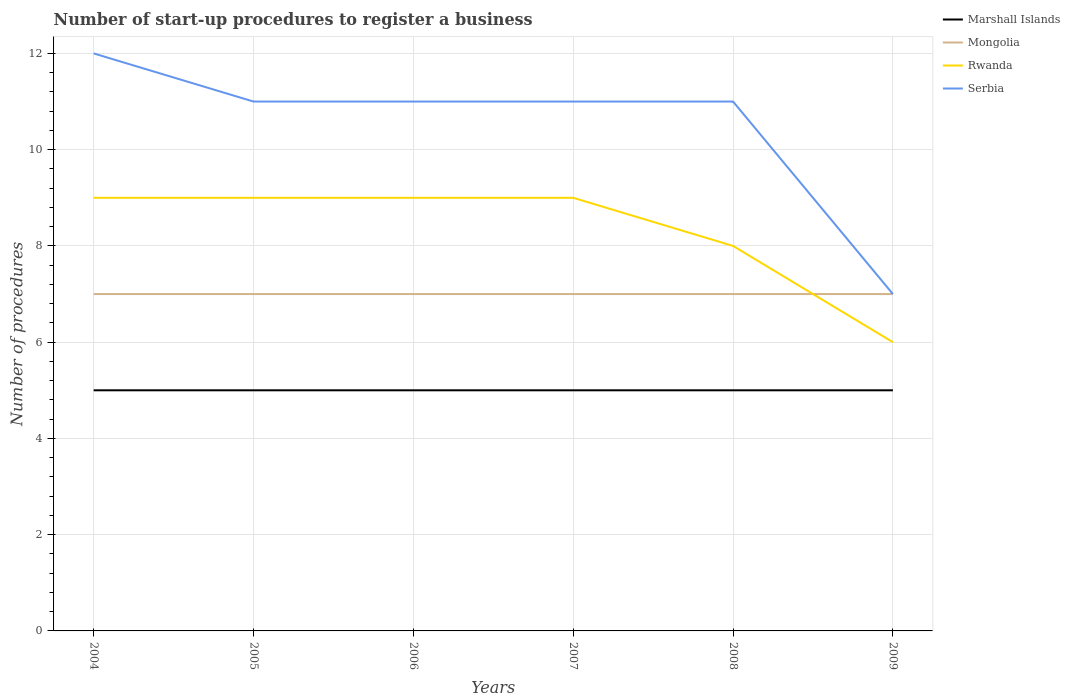How many different coloured lines are there?
Offer a terse response. 4. Does the line corresponding to Marshall Islands intersect with the line corresponding to Rwanda?
Ensure brevity in your answer.  No. Across all years, what is the maximum number of procedures required to register a business in Mongolia?
Offer a terse response. 7. In which year was the number of procedures required to register a business in Mongolia maximum?
Give a very brief answer. 2004. What is the difference between the highest and the second highest number of procedures required to register a business in Serbia?
Give a very brief answer. 5. How many years are there in the graph?
Offer a very short reply. 6. What is the difference between two consecutive major ticks on the Y-axis?
Provide a succinct answer. 2. Does the graph contain any zero values?
Your answer should be very brief. No. Does the graph contain grids?
Provide a succinct answer. Yes. How many legend labels are there?
Offer a very short reply. 4. How are the legend labels stacked?
Your answer should be compact. Vertical. What is the title of the graph?
Your answer should be very brief. Number of start-up procedures to register a business. Does "Luxembourg" appear as one of the legend labels in the graph?
Offer a very short reply. No. What is the label or title of the Y-axis?
Your response must be concise. Number of procedures. What is the Number of procedures of Marshall Islands in 2004?
Provide a succinct answer. 5. What is the Number of procedures of Rwanda in 2004?
Provide a succinct answer. 9. What is the Number of procedures of Marshall Islands in 2005?
Provide a short and direct response. 5. What is the Number of procedures of Rwanda in 2005?
Your response must be concise. 9. What is the Number of procedures in Mongolia in 2006?
Provide a short and direct response. 7. What is the Number of procedures in Rwanda in 2006?
Your answer should be very brief. 9. What is the Number of procedures of Mongolia in 2007?
Make the answer very short. 7. What is the Number of procedures in Rwanda in 2007?
Offer a terse response. 9. What is the Number of procedures in Mongolia in 2008?
Your answer should be compact. 7. What is the Number of procedures in Serbia in 2008?
Your answer should be compact. 11. What is the Number of procedures in Serbia in 2009?
Provide a succinct answer. 7. Across all years, what is the maximum Number of procedures of Marshall Islands?
Provide a succinct answer. 5. Across all years, what is the maximum Number of procedures in Mongolia?
Your answer should be compact. 7. Across all years, what is the maximum Number of procedures in Rwanda?
Keep it short and to the point. 9. Across all years, what is the minimum Number of procedures in Marshall Islands?
Your answer should be very brief. 5. Across all years, what is the minimum Number of procedures of Rwanda?
Offer a very short reply. 6. What is the total Number of procedures in Marshall Islands in the graph?
Ensure brevity in your answer.  30. What is the difference between the Number of procedures of Marshall Islands in 2004 and that in 2005?
Your response must be concise. 0. What is the difference between the Number of procedures of Mongolia in 2004 and that in 2005?
Offer a terse response. 0. What is the difference between the Number of procedures in Rwanda in 2004 and that in 2005?
Your response must be concise. 0. What is the difference between the Number of procedures in Serbia in 2004 and that in 2005?
Your answer should be compact. 1. What is the difference between the Number of procedures of Mongolia in 2004 and that in 2006?
Your answer should be very brief. 0. What is the difference between the Number of procedures of Serbia in 2004 and that in 2006?
Your answer should be compact. 1. What is the difference between the Number of procedures of Marshall Islands in 2004 and that in 2007?
Provide a succinct answer. 0. What is the difference between the Number of procedures in Serbia in 2004 and that in 2007?
Give a very brief answer. 1. What is the difference between the Number of procedures in Marshall Islands in 2004 and that in 2008?
Your response must be concise. 0. What is the difference between the Number of procedures in Rwanda in 2004 and that in 2008?
Offer a terse response. 1. What is the difference between the Number of procedures of Marshall Islands in 2004 and that in 2009?
Your answer should be very brief. 0. What is the difference between the Number of procedures of Mongolia in 2004 and that in 2009?
Offer a terse response. 0. What is the difference between the Number of procedures of Serbia in 2004 and that in 2009?
Provide a short and direct response. 5. What is the difference between the Number of procedures in Marshall Islands in 2005 and that in 2006?
Ensure brevity in your answer.  0. What is the difference between the Number of procedures in Mongolia in 2005 and that in 2006?
Offer a very short reply. 0. What is the difference between the Number of procedures in Rwanda in 2005 and that in 2006?
Ensure brevity in your answer.  0. What is the difference between the Number of procedures in Serbia in 2005 and that in 2006?
Keep it short and to the point. 0. What is the difference between the Number of procedures of Marshall Islands in 2005 and that in 2007?
Your answer should be compact. 0. What is the difference between the Number of procedures in Mongolia in 2005 and that in 2007?
Ensure brevity in your answer.  0. What is the difference between the Number of procedures of Marshall Islands in 2005 and that in 2008?
Ensure brevity in your answer.  0. What is the difference between the Number of procedures in Rwanda in 2005 and that in 2008?
Keep it short and to the point. 1. What is the difference between the Number of procedures of Serbia in 2005 and that in 2008?
Provide a short and direct response. 0. What is the difference between the Number of procedures of Mongolia in 2005 and that in 2009?
Keep it short and to the point. 0. What is the difference between the Number of procedures of Mongolia in 2006 and that in 2007?
Keep it short and to the point. 0. What is the difference between the Number of procedures in Serbia in 2006 and that in 2007?
Keep it short and to the point. 0. What is the difference between the Number of procedures in Mongolia in 2006 and that in 2008?
Your response must be concise. 0. What is the difference between the Number of procedures in Rwanda in 2006 and that in 2008?
Make the answer very short. 1. What is the difference between the Number of procedures in Serbia in 2006 and that in 2008?
Your answer should be very brief. 0. What is the difference between the Number of procedures in Marshall Islands in 2006 and that in 2009?
Ensure brevity in your answer.  0. What is the difference between the Number of procedures in Rwanda in 2006 and that in 2009?
Ensure brevity in your answer.  3. What is the difference between the Number of procedures of Marshall Islands in 2007 and that in 2008?
Keep it short and to the point. 0. What is the difference between the Number of procedures in Mongolia in 2007 and that in 2008?
Ensure brevity in your answer.  0. What is the difference between the Number of procedures of Rwanda in 2007 and that in 2008?
Your response must be concise. 1. What is the difference between the Number of procedures of Marshall Islands in 2007 and that in 2009?
Provide a short and direct response. 0. What is the difference between the Number of procedures in Mongolia in 2007 and that in 2009?
Make the answer very short. 0. What is the difference between the Number of procedures in Marshall Islands in 2008 and that in 2009?
Make the answer very short. 0. What is the difference between the Number of procedures of Mongolia in 2008 and that in 2009?
Keep it short and to the point. 0. What is the difference between the Number of procedures in Rwanda in 2008 and that in 2009?
Provide a succinct answer. 2. What is the difference between the Number of procedures of Serbia in 2008 and that in 2009?
Your answer should be compact. 4. What is the difference between the Number of procedures in Marshall Islands in 2004 and the Number of procedures in Mongolia in 2005?
Your answer should be very brief. -2. What is the difference between the Number of procedures of Marshall Islands in 2004 and the Number of procedures of Rwanda in 2005?
Give a very brief answer. -4. What is the difference between the Number of procedures of Mongolia in 2004 and the Number of procedures of Rwanda in 2005?
Provide a short and direct response. -2. What is the difference between the Number of procedures of Mongolia in 2004 and the Number of procedures of Serbia in 2005?
Provide a succinct answer. -4. What is the difference between the Number of procedures of Marshall Islands in 2004 and the Number of procedures of Mongolia in 2006?
Make the answer very short. -2. What is the difference between the Number of procedures in Rwanda in 2004 and the Number of procedures in Serbia in 2006?
Make the answer very short. -2. What is the difference between the Number of procedures in Marshall Islands in 2004 and the Number of procedures in Mongolia in 2007?
Provide a succinct answer. -2. What is the difference between the Number of procedures of Marshall Islands in 2004 and the Number of procedures of Rwanda in 2007?
Make the answer very short. -4. What is the difference between the Number of procedures of Mongolia in 2004 and the Number of procedures of Rwanda in 2007?
Make the answer very short. -2. What is the difference between the Number of procedures of Mongolia in 2004 and the Number of procedures of Serbia in 2007?
Ensure brevity in your answer.  -4. What is the difference between the Number of procedures in Marshall Islands in 2004 and the Number of procedures in Mongolia in 2008?
Offer a very short reply. -2. What is the difference between the Number of procedures of Marshall Islands in 2004 and the Number of procedures of Rwanda in 2008?
Give a very brief answer. -3. What is the difference between the Number of procedures in Marshall Islands in 2004 and the Number of procedures in Serbia in 2008?
Offer a very short reply. -6. What is the difference between the Number of procedures in Rwanda in 2004 and the Number of procedures in Serbia in 2008?
Ensure brevity in your answer.  -2. What is the difference between the Number of procedures in Marshall Islands in 2004 and the Number of procedures in Mongolia in 2009?
Your response must be concise. -2. What is the difference between the Number of procedures in Marshall Islands in 2004 and the Number of procedures in Rwanda in 2009?
Offer a very short reply. -1. What is the difference between the Number of procedures of Mongolia in 2004 and the Number of procedures of Rwanda in 2009?
Give a very brief answer. 1. What is the difference between the Number of procedures in Marshall Islands in 2005 and the Number of procedures in Mongolia in 2006?
Offer a terse response. -2. What is the difference between the Number of procedures of Marshall Islands in 2005 and the Number of procedures of Rwanda in 2006?
Your response must be concise. -4. What is the difference between the Number of procedures in Marshall Islands in 2005 and the Number of procedures in Serbia in 2006?
Your answer should be compact. -6. What is the difference between the Number of procedures of Mongolia in 2005 and the Number of procedures of Rwanda in 2006?
Give a very brief answer. -2. What is the difference between the Number of procedures of Mongolia in 2005 and the Number of procedures of Serbia in 2006?
Provide a succinct answer. -4. What is the difference between the Number of procedures of Marshall Islands in 2005 and the Number of procedures of Mongolia in 2007?
Provide a succinct answer. -2. What is the difference between the Number of procedures of Mongolia in 2005 and the Number of procedures of Rwanda in 2007?
Your response must be concise. -2. What is the difference between the Number of procedures in Mongolia in 2005 and the Number of procedures in Serbia in 2007?
Make the answer very short. -4. What is the difference between the Number of procedures in Mongolia in 2005 and the Number of procedures in Rwanda in 2008?
Your answer should be compact. -1. What is the difference between the Number of procedures of Mongolia in 2005 and the Number of procedures of Serbia in 2008?
Provide a short and direct response. -4. What is the difference between the Number of procedures of Marshall Islands in 2005 and the Number of procedures of Mongolia in 2009?
Keep it short and to the point. -2. What is the difference between the Number of procedures in Mongolia in 2005 and the Number of procedures in Serbia in 2009?
Your response must be concise. 0. What is the difference between the Number of procedures in Marshall Islands in 2006 and the Number of procedures in Mongolia in 2007?
Offer a very short reply. -2. What is the difference between the Number of procedures of Marshall Islands in 2006 and the Number of procedures of Rwanda in 2007?
Keep it short and to the point. -4. What is the difference between the Number of procedures of Marshall Islands in 2006 and the Number of procedures of Serbia in 2007?
Make the answer very short. -6. What is the difference between the Number of procedures in Mongolia in 2006 and the Number of procedures in Rwanda in 2007?
Give a very brief answer. -2. What is the difference between the Number of procedures in Rwanda in 2006 and the Number of procedures in Serbia in 2007?
Offer a very short reply. -2. What is the difference between the Number of procedures in Marshall Islands in 2006 and the Number of procedures in Mongolia in 2008?
Keep it short and to the point. -2. What is the difference between the Number of procedures of Mongolia in 2006 and the Number of procedures of Rwanda in 2008?
Make the answer very short. -1. What is the difference between the Number of procedures in Marshall Islands in 2006 and the Number of procedures in Mongolia in 2009?
Make the answer very short. -2. What is the difference between the Number of procedures of Marshall Islands in 2006 and the Number of procedures of Rwanda in 2009?
Give a very brief answer. -1. What is the difference between the Number of procedures in Mongolia in 2006 and the Number of procedures in Serbia in 2009?
Provide a succinct answer. 0. What is the difference between the Number of procedures of Rwanda in 2006 and the Number of procedures of Serbia in 2009?
Provide a short and direct response. 2. What is the difference between the Number of procedures in Marshall Islands in 2007 and the Number of procedures in Mongolia in 2008?
Your response must be concise. -2. What is the difference between the Number of procedures of Rwanda in 2007 and the Number of procedures of Serbia in 2008?
Your answer should be very brief. -2. What is the difference between the Number of procedures of Marshall Islands in 2007 and the Number of procedures of Rwanda in 2009?
Your answer should be compact. -1. What is the difference between the Number of procedures of Marshall Islands in 2008 and the Number of procedures of Mongolia in 2009?
Provide a succinct answer. -2. What is the difference between the Number of procedures of Marshall Islands in 2008 and the Number of procedures of Serbia in 2009?
Your response must be concise. -2. What is the difference between the Number of procedures of Mongolia in 2008 and the Number of procedures of Rwanda in 2009?
Make the answer very short. 1. What is the difference between the Number of procedures of Mongolia in 2008 and the Number of procedures of Serbia in 2009?
Your answer should be very brief. 0. What is the difference between the Number of procedures of Rwanda in 2008 and the Number of procedures of Serbia in 2009?
Your answer should be compact. 1. What is the average Number of procedures of Marshall Islands per year?
Your response must be concise. 5. What is the average Number of procedures of Mongolia per year?
Ensure brevity in your answer.  7. What is the average Number of procedures in Rwanda per year?
Provide a short and direct response. 8.33. In the year 2004, what is the difference between the Number of procedures in Marshall Islands and Number of procedures in Mongolia?
Make the answer very short. -2. In the year 2004, what is the difference between the Number of procedures in Mongolia and Number of procedures in Rwanda?
Offer a very short reply. -2. In the year 2004, what is the difference between the Number of procedures in Rwanda and Number of procedures in Serbia?
Your answer should be very brief. -3. In the year 2005, what is the difference between the Number of procedures of Marshall Islands and Number of procedures of Mongolia?
Offer a terse response. -2. In the year 2005, what is the difference between the Number of procedures in Rwanda and Number of procedures in Serbia?
Your response must be concise. -2. In the year 2006, what is the difference between the Number of procedures of Marshall Islands and Number of procedures of Mongolia?
Your answer should be very brief. -2. In the year 2006, what is the difference between the Number of procedures of Marshall Islands and Number of procedures of Rwanda?
Your answer should be compact. -4. In the year 2006, what is the difference between the Number of procedures in Marshall Islands and Number of procedures in Serbia?
Your answer should be very brief. -6. In the year 2006, what is the difference between the Number of procedures in Mongolia and Number of procedures in Rwanda?
Provide a short and direct response. -2. In the year 2007, what is the difference between the Number of procedures of Marshall Islands and Number of procedures of Mongolia?
Your response must be concise. -2. In the year 2007, what is the difference between the Number of procedures in Marshall Islands and Number of procedures in Rwanda?
Keep it short and to the point. -4. In the year 2007, what is the difference between the Number of procedures in Marshall Islands and Number of procedures in Serbia?
Ensure brevity in your answer.  -6. In the year 2007, what is the difference between the Number of procedures of Mongolia and Number of procedures of Serbia?
Your answer should be very brief. -4. In the year 2008, what is the difference between the Number of procedures of Marshall Islands and Number of procedures of Rwanda?
Provide a succinct answer. -3. In the year 2008, what is the difference between the Number of procedures of Mongolia and Number of procedures of Serbia?
Your response must be concise. -4. In the year 2009, what is the difference between the Number of procedures of Marshall Islands and Number of procedures of Rwanda?
Offer a very short reply. -1. In the year 2009, what is the difference between the Number of procedures in Marshall Islands and Number of procedures in Serbia?
Ensure brevity in your answer.  -2. In the year 2009, what is the difference between the Number of procedures in Mongolia and Number of procedures in Rwanda?
Your response must be concise. 1. In the year 2009, what is the difference between the Number of procedures of Rwanda and Number of procedures of Serbia?
Offer a terse response. -1. What is the ratio of the Number of procedures of Rwanda in 2004 to that in 2005?
Your answer should be compact. 1. What is the ratio of the Number of procedures of Serbia in 2004 to that in 2005?
Your answer should be very brief. 1.09. What is the ratio of the Number of procedures in Marshall Islands in 2004 to that in 2006?
Give a very brief answer. 1. What is the ratio of the Number of procedures in Mongolia in 2004 to that in 2006?
Make the answer very short. 1. What is the ratio of the Number of procedures in Rwanda in 2004 to that in 2006?
Your response must be concise. 1. What is the ratio of the Number of procedures in Mongolia in 2004 to that in 2007?
Keep it short and to the point. 1. What is the ratio of the Number of procedures in Rwanda in 2004 to that in 2009?
Make the answer very short. 1.5. What is the ratio of the Number of procedures in Serbia in 2004 to that in 2009?
Provide a short and direct response. 1.71. What is the ratio of the Number of procedures in Marshall Islands in 2005 to that in 2006?
Provide a short and direct response. 1. What is the ratio of the Number of procedures in Serbia in 2005 to that in 2006?
Make the answer very short. 1. What is the ratio of the Number of procedures in Mongolia in 2005 to that in 2007?
Your answer should be compact. 1. What is the ratio of the Number of procedures in Mongolia in 2005 to that in 2008?
Offer a very short reply. 1. What is the ratio of the Number of procedures in Marshall Islands in 2005 to that in 2009?
Your answer should be compact. 1. What is the ratio of the Number of procedures in Rwanda in 2005 to that in 2009?
Offer a terse response. 1.5. What is the ratio of the Number of procedures in Serbia in 2005 to that in 2009?
Provide a succinct answer. 1.57. What is the ratio of the Number of procedures in Mongolia in 2006 to that in 2007?
Give a very brief answer. 1. What is the ratio of the Number of procedures of Serbia in 2006 to that in 2007?
Give a very brief answer. 1. What is the ratio of the Number of procedures in Serbia in 2006 to that in 2008?
Offer a very short reply. 1. What is the ratio of the Number of procedures in Mongolia in 2006 to that in 2009?
Make the answer very short. 1. What is the ratio of the Number of procedures of Serbia in 2006 to that in 2009?
Your answer should be compact. 1.57. What is the ratio of the Number of procedures in Mongolia in 2007 to that in 2008?
Keep it short and to the point. 1. What is the ratio of the Number of procedures of Rwanda in 2007 to that in 2008?
Offer a very short reply. 1.12. What is the ratio of the Number of procedures of Rwanda in 2007 to that in 2009?
Provide a short and direct response. 1.5. What is the ratio of the Number of procedures of Serbia in 2007 to that in 2009?
Your answer should be very brief. 1.57. What is the ratio of the Number of procedures of Marshall Islands in 2008 to that in 2009?
Provide a short and direct response. 1. What is the ratio of the Number of procedures in Mongolia in 2008 to that in 2009?
Your answer should be very brief. 1. What is the ratio of the Number of procedures in Serbia in 2008 to that in 2009?
Provide a succinct answer. 1.57. What is the difference between the highest and the second highest Number of procedures in Mongolia?
Your answer should be very brief. 0. What is the difference between the highest and the second highest Number of procedures of Rwanda?
Provide a succinct answer. 0. What is the difference between the highest and the second highest Number of procedures in Serbia?
Provide a succinct answer. 1. What is the difference between the highest and the lowest Number of procedures in Mongolia?
Provide a short and direct response. 0. 